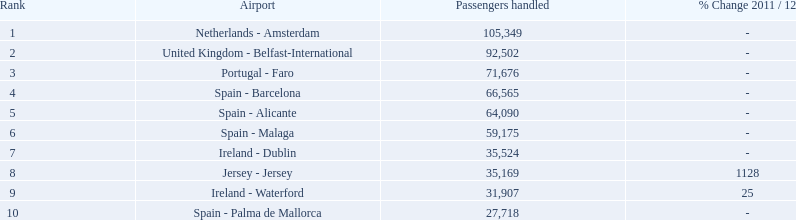What is the peak number of passengers processed? 105,349. What is the final destination for passengers exiting the zone that caters to 105,349 people? Netherlands - Amsterdam. 